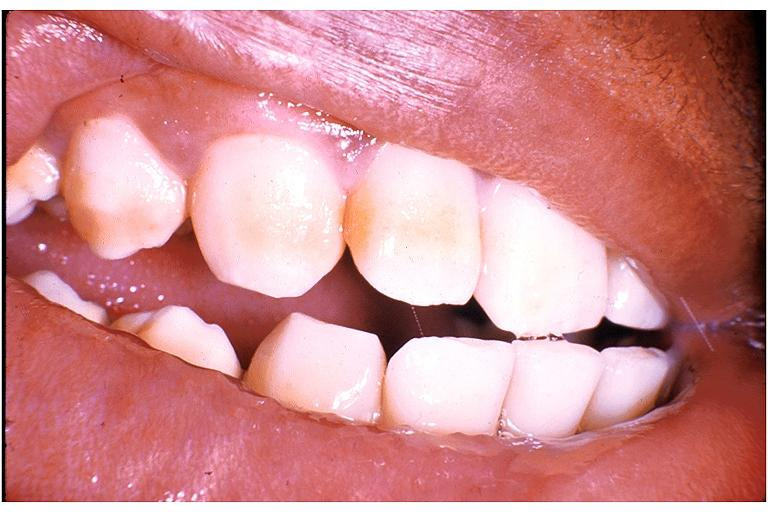does the superior vena cava show fluorosis?
Answer the question using a single word or phrase. No 